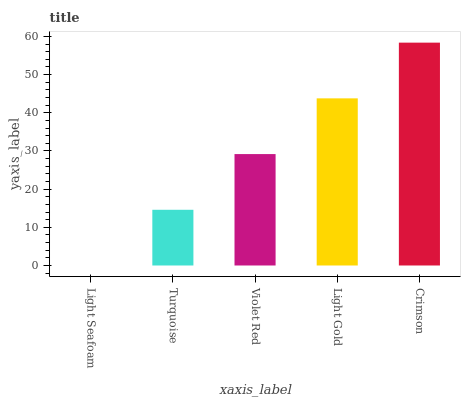Is Turquoise the minimum?
Answer yes or no. No. Is Turquoise the maximum?
Answer yes or no. No. Is Turquoise greater than Light Seafoam?
Answer yes or no. Yes. Is Light Seafoam less than Turquoise?
Answer yes or no. Yes. Is Light Seafoam greater than Turquoise?
Answer yes or no. No. Is Turquoise less than Light Seafoam?
Answer yes or no. No. Is Violet Red the high median?
Answer yes or no. Yes. Is Violet Red the low median?
Answer yes or no. Yes. Is Crimson the high median?
Answer yes or no. No. Is Turquoise the low median?
Answer yes or no. No. 